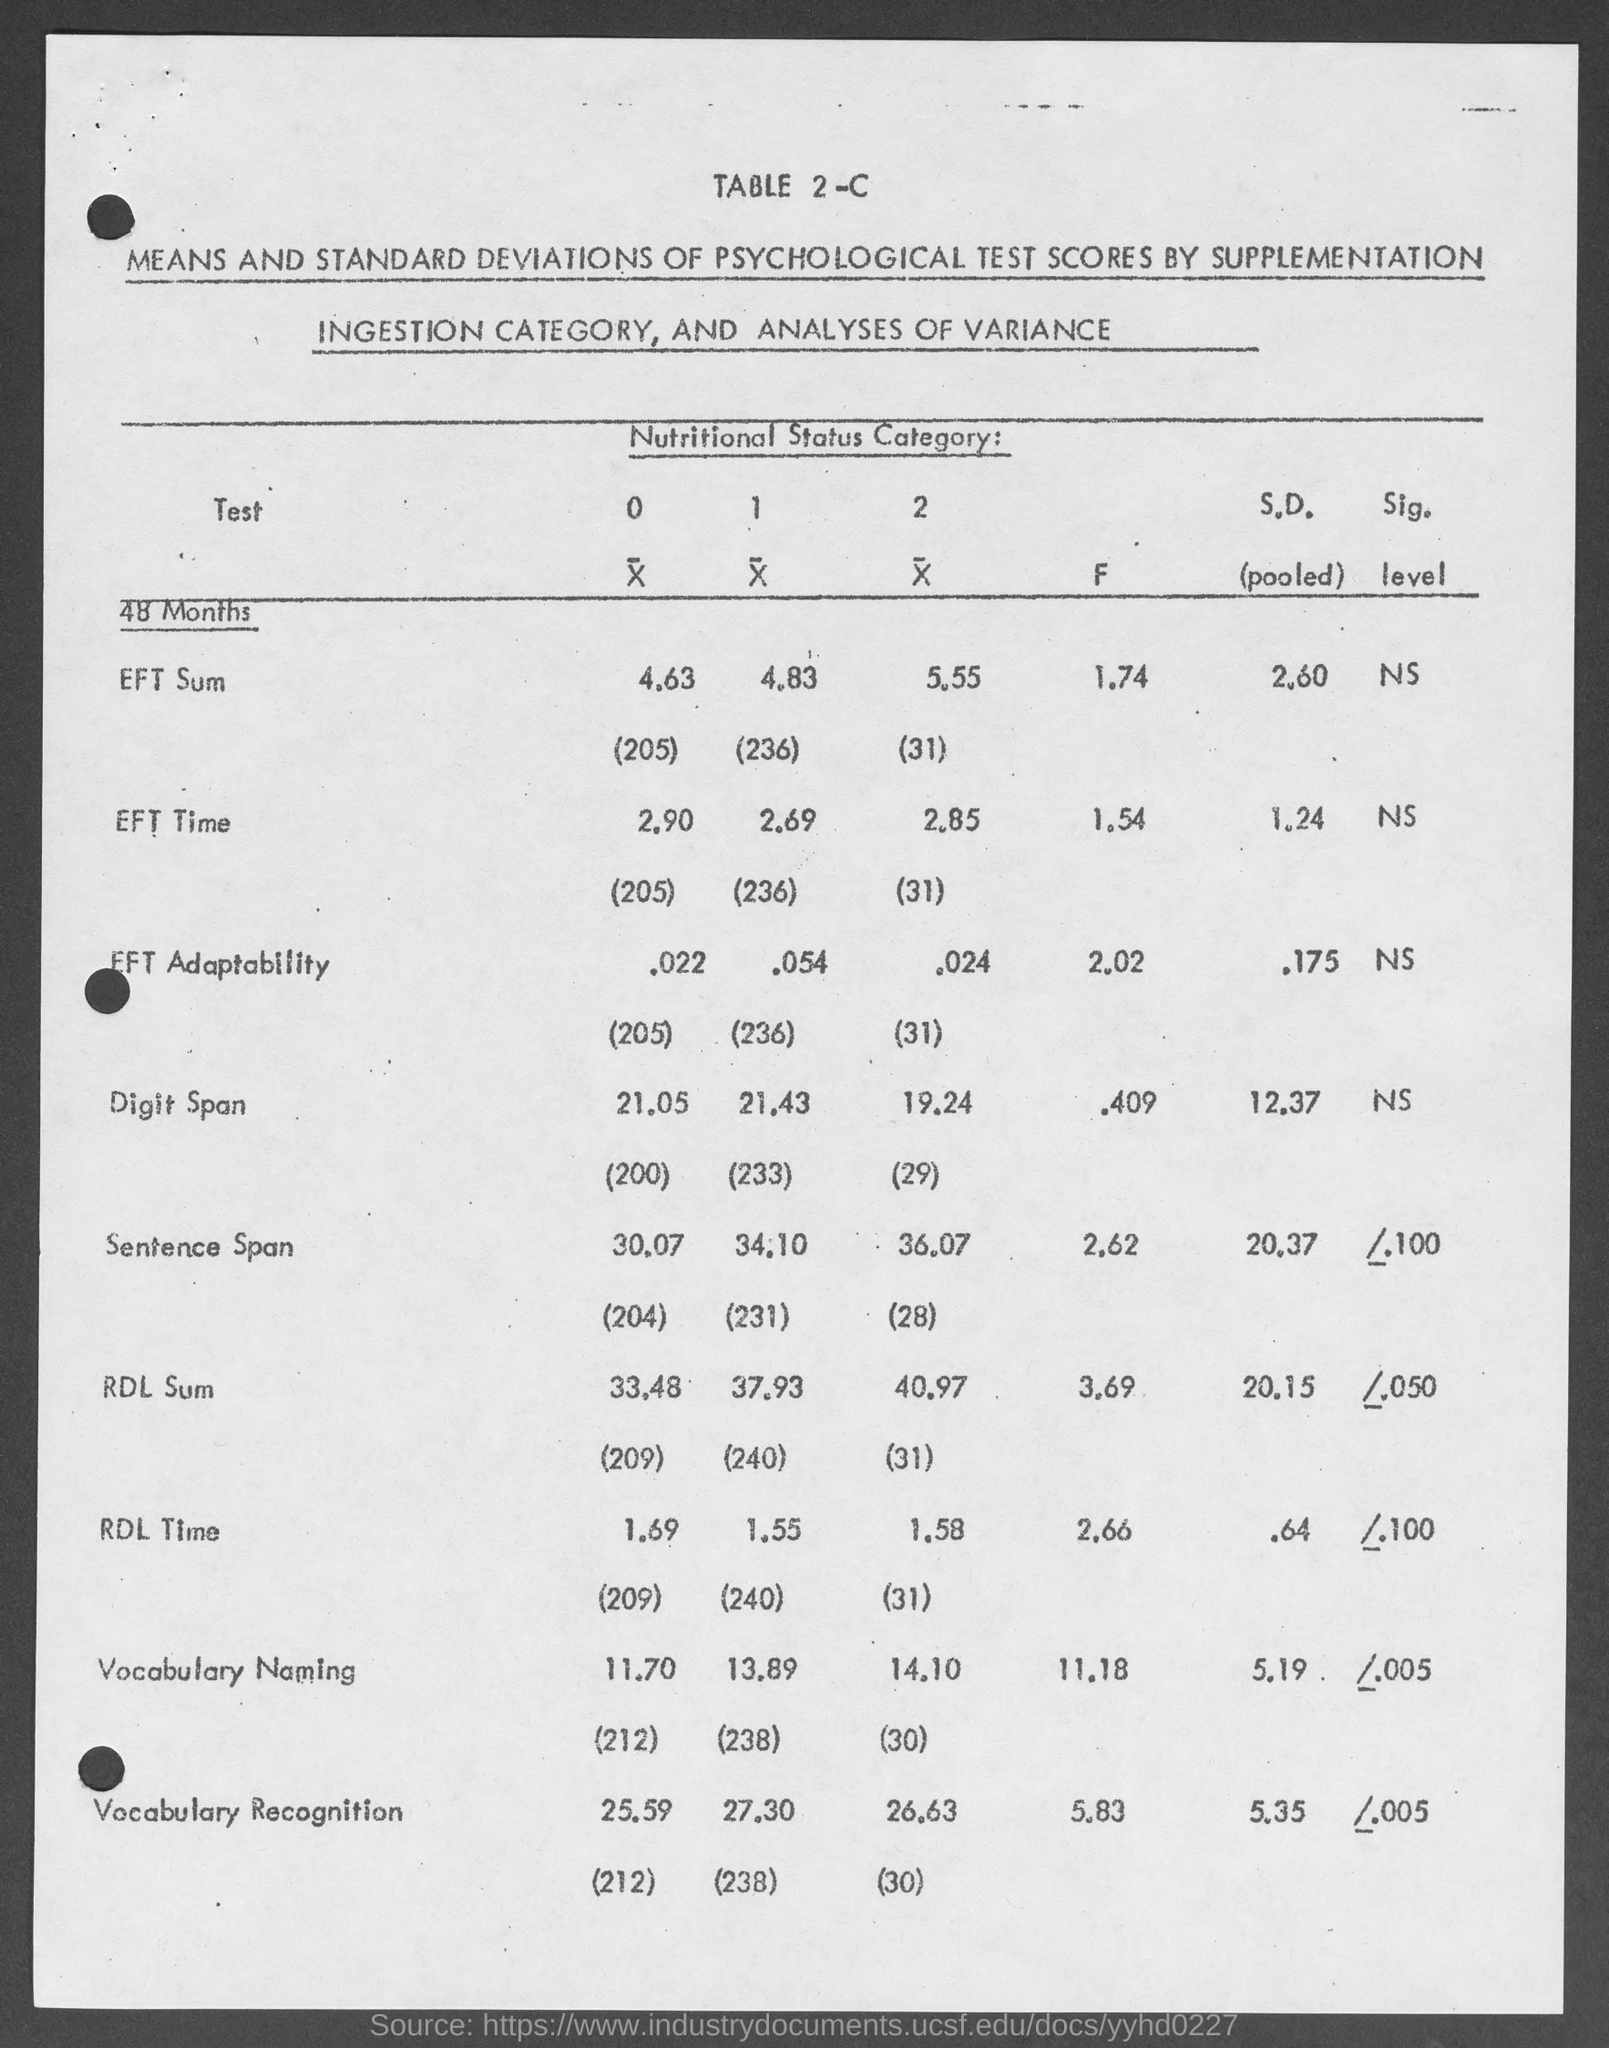What is the f value of eft sum?
Your answer should be very brief. 1.74. What is the f value of eft time ?
Your answer should be very brief. 1.54. What is the f  value for eft adaptability ?
Your response must be concise. 2.02. What is the f value for digit span ?
Provide a short and direct response. .409. What is the f value for sentence span?
Give a very brief answer. 2.62. What is the f value for rdl sum ?
Offer a very short reply. 3.69. What is the f value for rdl time ?
Your answer should be compact. 2.66. What is the f value for vocabulary naming ?
Keep it short and to the point. 11.18. What is the f value for vocabulary recognition ?
Your response must be concise. 5.83. 